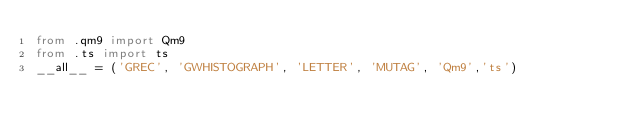Convert code to text. <code><loc_0><loc_0><loc_500><loc_500><_Python_>from .qm9 import Qm9
from .ts import ts
__all__ = ('GREC', 'GWHISTOGRAPH', 'LETTER', 'MUTAG', 'Qm9','ts')
</code> 